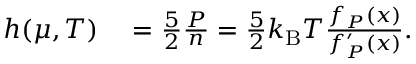Convert formula to latex. <formula><loc_0><loc_0><loc_500><loc_500>\begin{array} { r l } { h ( \mu , T ) } & = \frac { 5 } { 2 } \frac { P } { n } = \frac { 5 } { 2 } k _ { B } T \frac { f _ { P } ( x ) } { f _ { P } ^ { \prime } ( x ) } . } \end{array}</formula> 